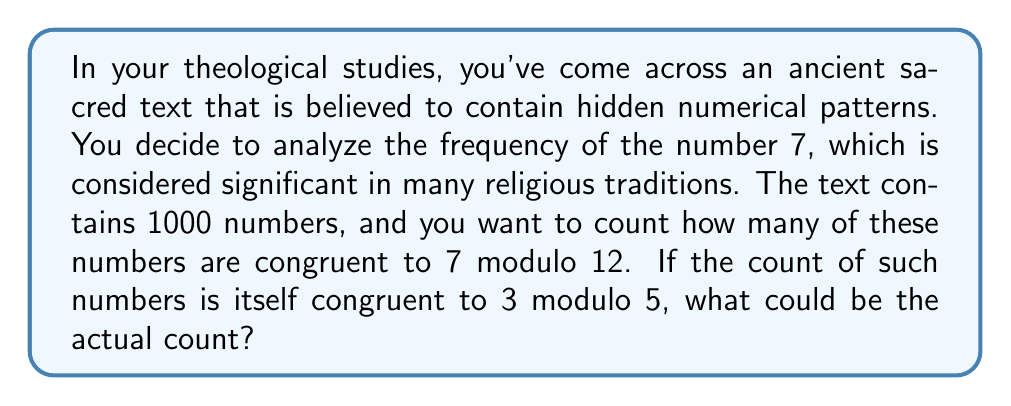Could you help me with this problem? Let's approach this step-by-step:

1) First, we need to understand what it means for a number to be congruent to 7 modulo 12. This can be expressed mathematically as:

   $n \equiv 7 \pmod{12}$

   This means that when n is divided by 12, the remainder is 7.

2) The question states that the count of such numbers is congruent to 3 modulo 5. We can express this as:

   $count \equiv 3 \pmod{5}$

3) This means that when the count is divided by 5, the remainder is 3. We can express this algebraically as:

   $count = 5k + 3$, where k is some non-negative integer.

4) Given that there are 1000 numbers in total, the count must be between 0 and 1000.

5) Let's list out the possible values for count:

   When $k = 0$: $count = 5(0) + 3 = 3$
   When $k = 1$: $count = 5(1) + 3 = 8$
   When $k = 2$: $count = 5(2) + 3 = 13$
   ...
   When $k = 199$: $count = 5(199) + 3 = 998$

6) Any of these values could be the actual count. However, we're looking for a number that's reasonable given the context. In a set of 1000 random numbers, we would expect about 1/12 of them (around 83) to be congruent to 7 modulo 12.

7) The closest value to 83 in our list is 83 itself, which occurs when $k = 16$:

   $count = 5(16) + 3 = 83$

Therefore, 83 is a reasonable answer for the actual count.
Answer: 83 